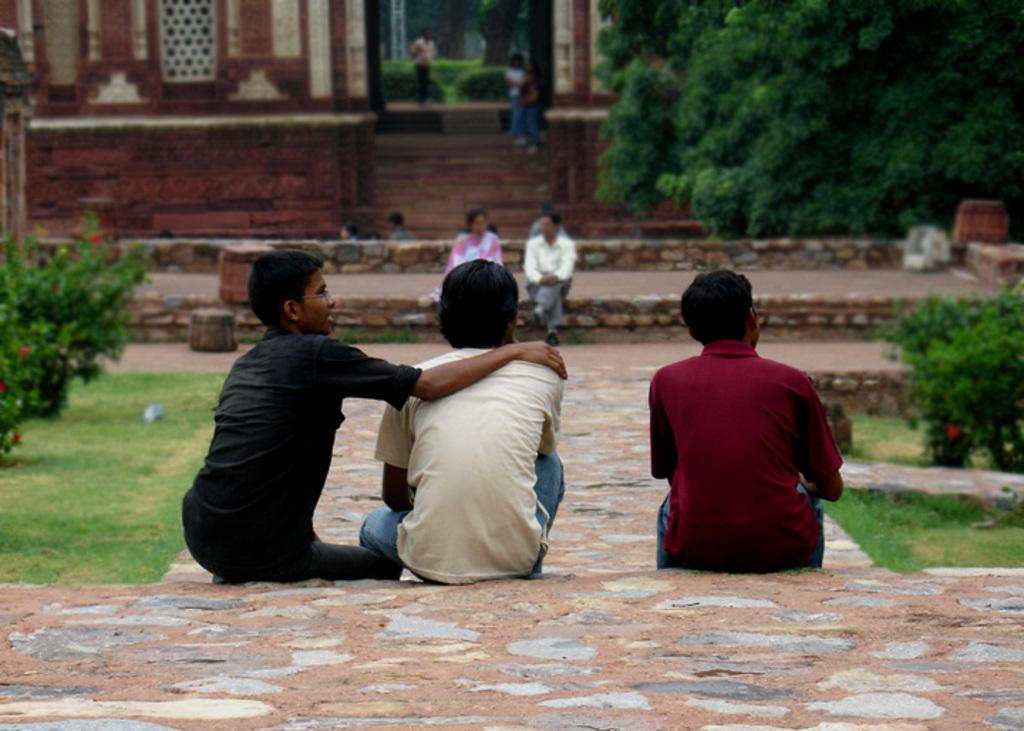What type of structure is visible in the image? There is a building in the image. What type of natural environment is present in the image? There is a grassy land and a tree in the image. What type of vegetation is present in the image? There are many plants in the image. How many people can be seen in the image? There are many people in the image. What type of bird is sitting on the wren in the image? There is no wren present in the image. What type of place is depicted in the image? The image does not depict a specific place; it shows a building, grassy land, a tree, plants, and people. 